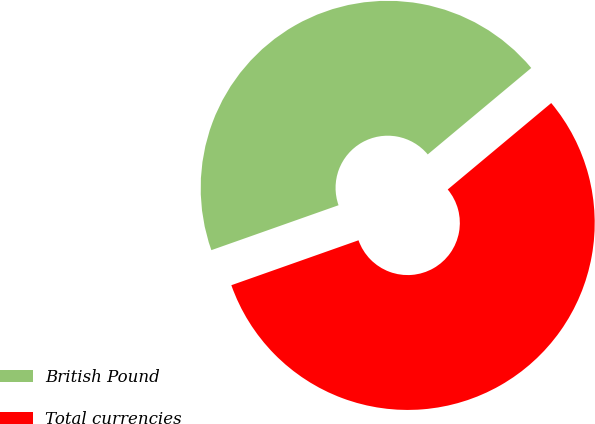Convert chart to OTSL. <chart><loc_0><loc_0><loc_500><loc_500><pie_chart><fcel>British Pound<fcel>Total currencies<nl><fcel>44.33%<fcel>55.67%<nl></chart> 